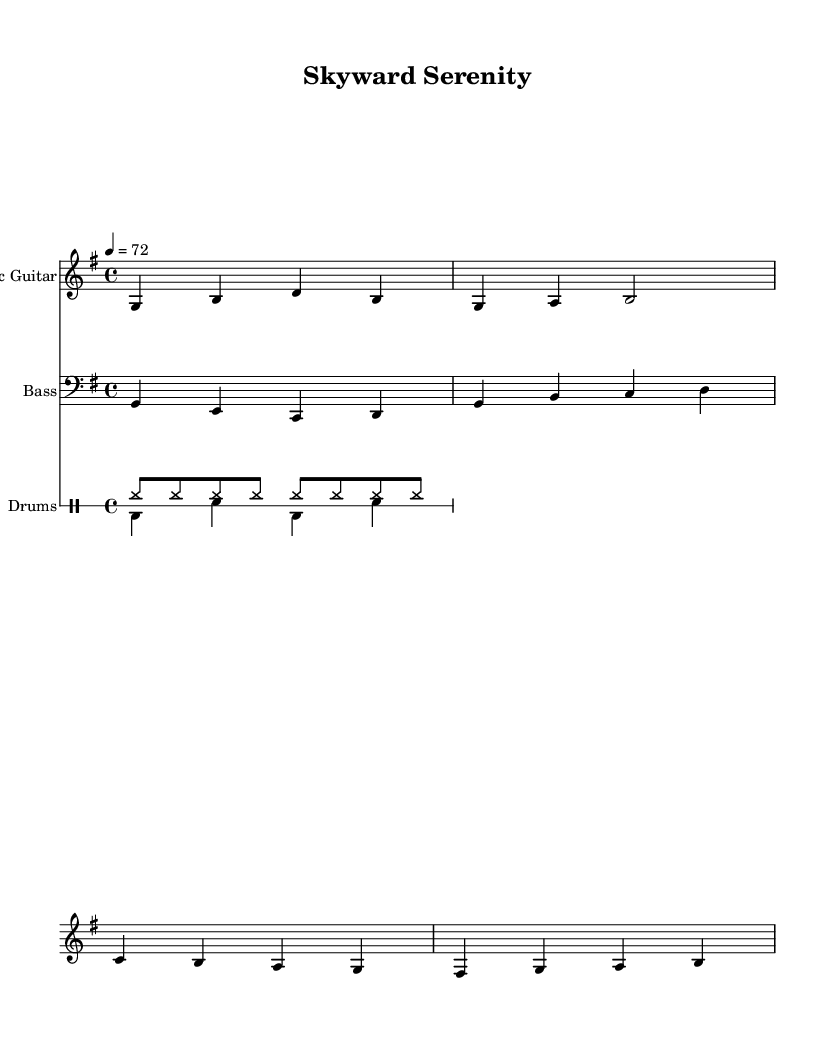What is the key signature of this music? The key signature is G major, which contains one sharp note (F#). The presence of an F# indicates that the music is in G major.
Answer: G major What is the time signature used in this piece? The time signature is indicated at the beginning of the music and is shown as 4/4, meaning there are four beats in each measure.
Answer: 4/4 What is the tempo marking for this composition? The tempo is indicated as a quarter note = 72, which means the piece should be played at a speed of 72 quarter notes per minute.
Answer: 72 How many measures are in the electric guitar part? Counting the individual groupings (bars), the electric guitar part has four measures total.
Answer: 4 What connections can be made between the bass and electric guitar in terms of notes played? The bass guitar part complements the electric guitar by playing root notes in sync with the guitar chords, specifically focusing on the G note while the guitar plays parts based on G major. This creates a harmonious connection typical in reggae music.
Answer: Root notes How does the drum pattern contribute to the laid-back feel of the piece? The drum pattern features a steady rhythm using the hi-hat for consistent beats and a simple bass-snare alternation that maintains a relaxed groove, characteristic of reggae, supporting the overall laid-back ambiance of the composition.
Answer: Relaxed groove 